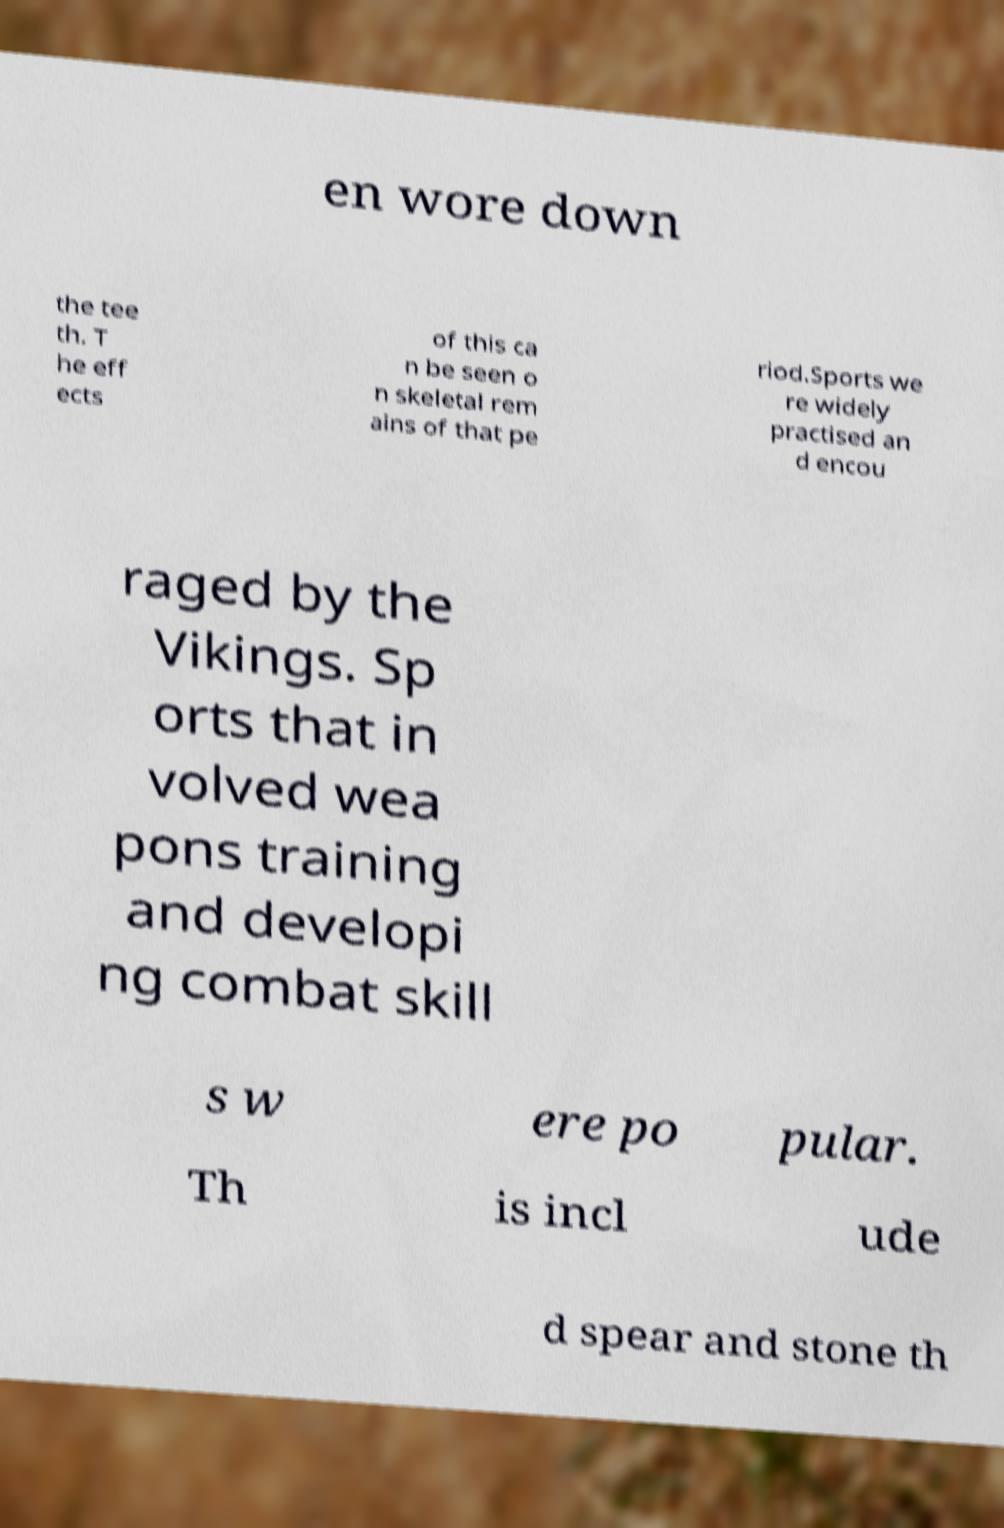Could you assist in decoding the text presented in this image and type it out clearly? en wore down the tee th. T he eff ects of this ca n be seen o n skeletal rem ains of that pe riod.Sports we re widely practised an d encou raged by the Vikings. Sp orts that in volved wea pons training and developi ng combat skill s w ere po pular. Th is incl ude d spear and stone th 